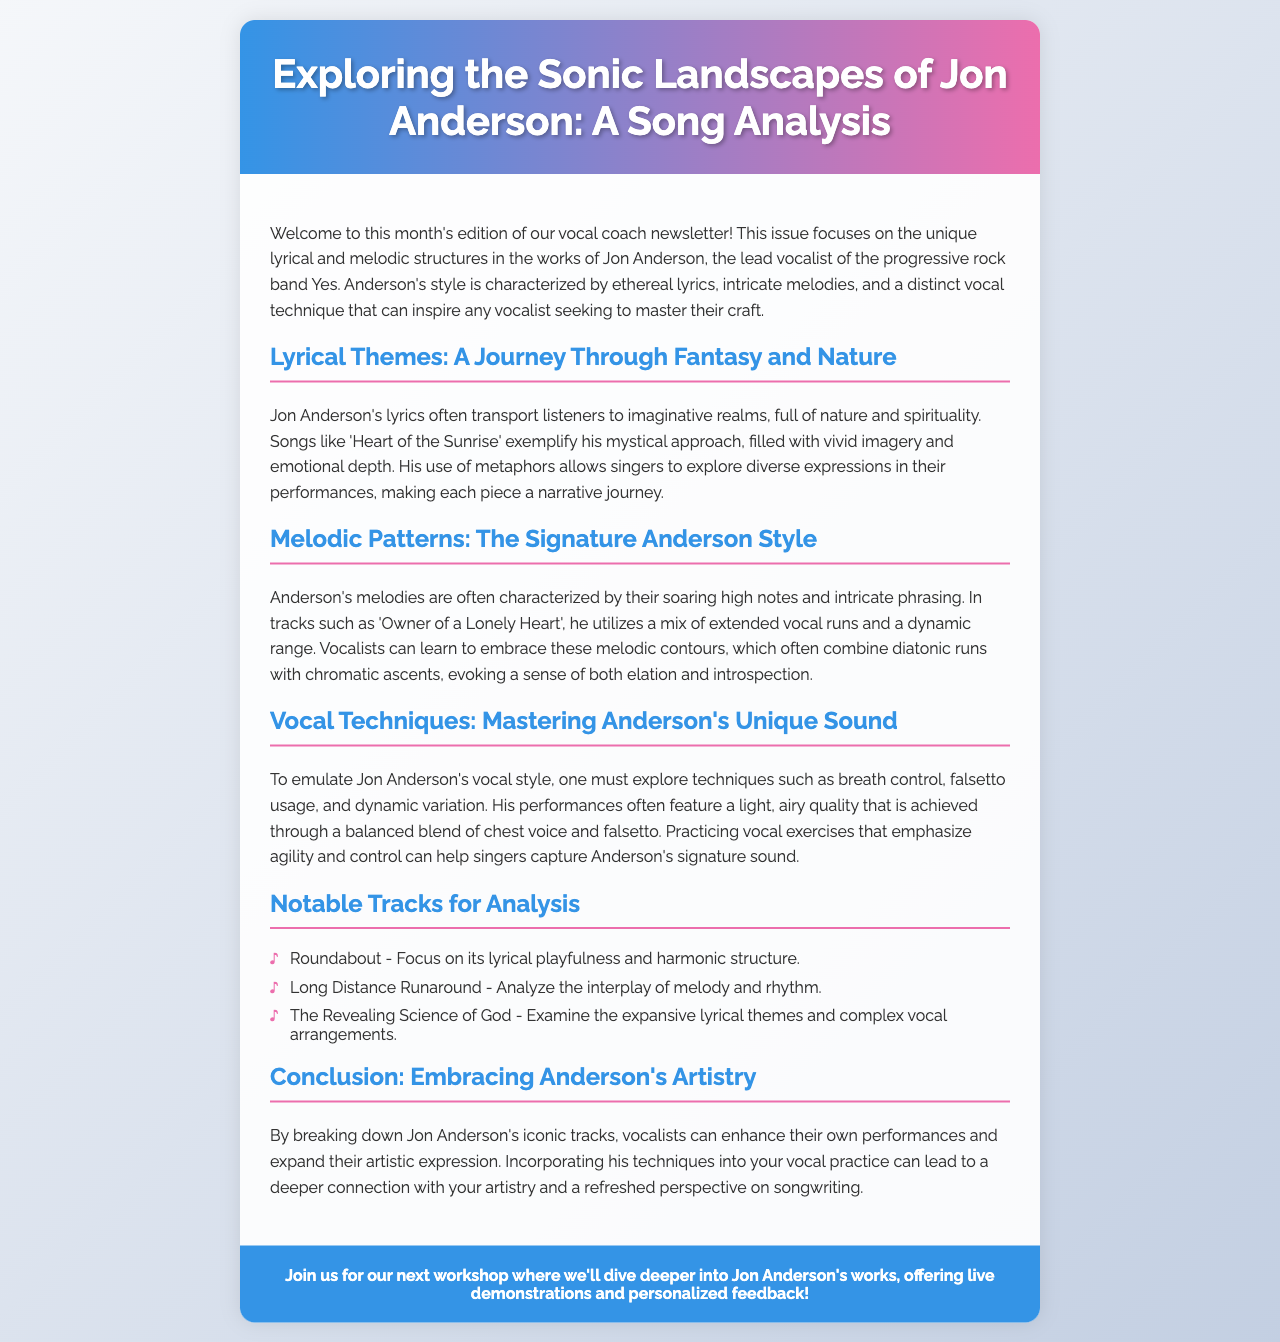What is the title of the newsletter? The title of the newsletter, as mentioned in the header, is "Exploring the Sonic Landscapes of Jon Anderson: A Song Analysis".
Answer: Exploring the Sonic Landscapes of Jon Anderson: A Song Analysis Who is the lead vocalist of Yes? The newsletter identifies Jon Anderson as the lead vocalist of the band Yes.
Answer: Jon Anderson Which song exemplifies Anderson's mystical approach? The newsletter highlights "Heart of the Sunrise" as an example of Jon Anderson's mystical lyrical style.
Answer: Heart of the Sunrise What vocal techniques are emphasized for emulating Anderson's sound? The document discusses breath control, falsetto usage, and dynamic variation as key techniques to emulate Jon Anderson's style.
Answer: Breath control, falsetto usage, dynamic variation What is the focus in analyzing the song "Roundabout"? The newsletter states that the focus in analyzing "Roundabout" is on its lyrical playfulness and harmonic structure.
Answer: Lyrical playfulness and harmonic structure What quality does Anderson's vocal performance often feature? The document mentions that Anderson's performances often feature a light, airy quality.
Answer: Light, airy quality How many notable tracks are suggested for analysis? The newsletter lists three notable tracks for analysis.
Answer: Three What is emphasized as beneficial for vocalists in the conclusion? The conclusion emphasizes that breaking down Jon Anderson's iconic tracks can enhance vocalists' performances and artistic expression.
Answer: Enhance performances and artistic expression 